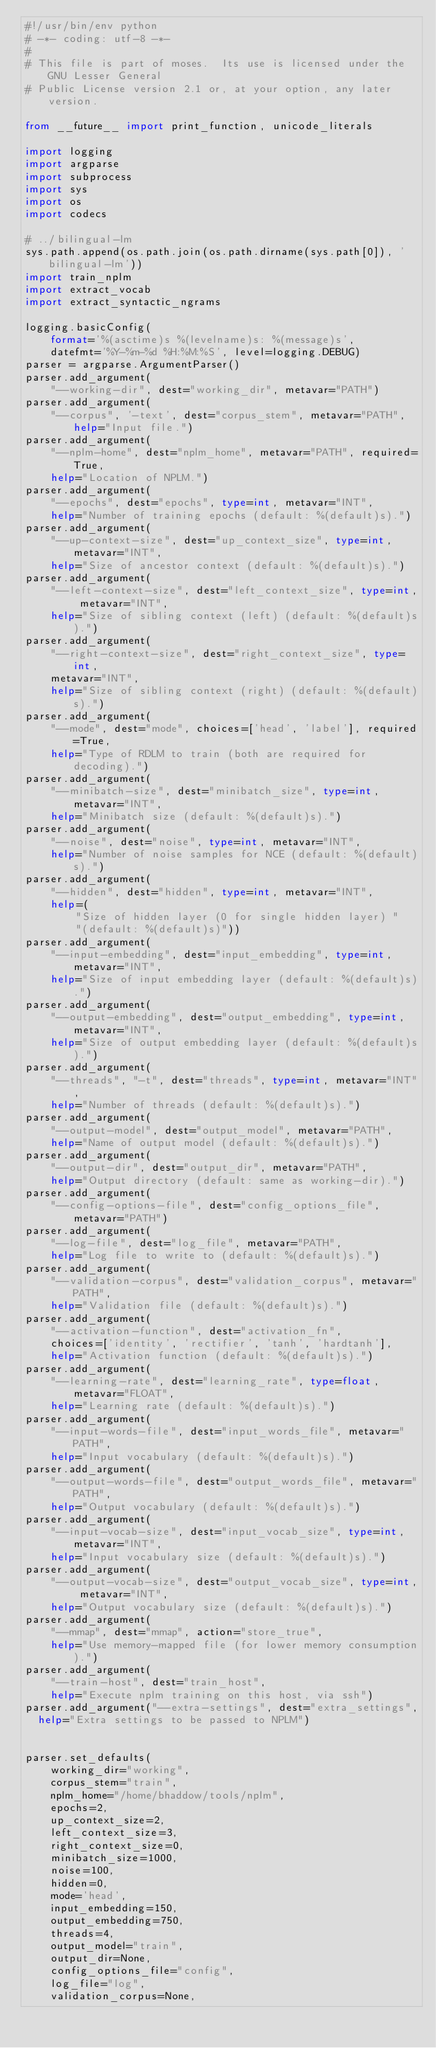<code> <loc_0><loc_0><loc_500><loc_500><_Python_>#!/usr/bin/env python
# -*- coding: utf-8 -*-
#
# This file is part of moses.  Its use is licensed under the GNU Lesser General
# Public License version 2.1 or, at your option, any later version.

from __future__ import print_function, unicode_literals

import logging
import argparse
import subprocess
import sys
import os
import codecs

# ../bilingual-lm
sys.path.append(os.path.join(os.path.dirname(sys.path[0]), 'bilingual-lm'))
import train_nplm
import extract_vocab
import extract_syntactic_ngrams

logging.basicConfig(
    format='%(asctime)s %(levelname)s: %(message)s',
    datefmt='%Y-%m-%d %H:%M:%S', level=logging.DEBUG)
parser = argparse.ArgumentParser()
parser.add_argument(
    "--working-dir", dest="working_dir", metavar="PATH")
parser.add_argument(
    "--corpus", '-text', dest="corpus_stem", metavar="PATH", help="Input file.")
parser.add_argument(
    "--nplm-home", dest="nplm_home", metavar="PATH", required=True,
    help="Location of NPLM.")
parser.add_argument(
    "--epochs", dest="epochs", type=int, metavar="INT",
    help="Number of training epochs (default: %(default)s).")
parser.add_argument(
    "--up-context-size", dest="up_context_size", type=int, metavar="INT",
    help="Size of ancestor context (default: %(default)s).")
parser.add_argument(
    "--left-context-size", dest="left_context_size", type=int, metavar="INT",
    help="Size of sibling context (left) (default: %(default)s).")
parser.add_argument(
    "--right-context-size", dest="right_context_size", type=int,
    metavar="INT",
    help="Size of sibling context (right) (default: %(default)s).")
parser.add_argument(
    "--mode", dest="mode", choices=['head', 'label'], required=True,
    help="Type of RDLM to train (both are required for decoding).")
parser.add_argument(
    "--minibatch-size", dest="minibatch_size", type=int, metavar="INT",
    help="Minibatch size (default: %(default)s).")
parser.add_argument(
    "--noise", dest="noise", type=int, metavar="INT",
    help="Number of noise samples for NCE (default: %(default)s).")
parser.add_argument(
    "--hidden", dest="hidden", type=int, metavar="INT",
    help=(
        "Size of hidden layer (0 for single hidden layer) "
        "(default: %(default)s)"))
parser.add_argument(
    "--input-embedding", dest="input_embedding", type=int, metavar="INT",
    help="Size of input embedding layer (default: %(default)s).")
parser.add_argument(
    "--output-embedding", dest="output_embedding", type=int, metavar="INT",
    help="Size of output embedding layer (default: %(default)s).")
parser.add_argument(
    "--threads", "-t", dest="threads", type=int, metavar="INT",
    help="Number of threads (default: %(default)s).")
parser.add_argument(
    "--output-model", dest="output_model", metavar="PATH",
    help="Name of output model (default: %(default)s).")
parser.add_argument(
    "--output-dir", dest="output_dir", metavar="PATH",
    help="Output directory (default: same as working-dir).")
parser.add_argument(
    "--config-options-file", dest="config_options_file", metavar="PATH")
parser.add_argument(
    "--log-file", dest="log_file", metavar="PATH",
    help="Log file to write to (default: %(default)s).")
parser.add_argument(
    "--validation-corpus", dest="validation_corpus", metavar="PATH",
    help="Validation file (default: %(default)s).")
parser.add_argument(
    "--activation-function", dest="activation_fn",
    choices=['identity', 'rectifier', 'tanh', 'hardtanh'],
    help="Activation function (default: %(default)s).")
parser.add_argument(
    "--learning-rate", dest="learning_rate", type=float, metavar="FLOAT",
    help="Learning rate (default: %(default)s).")
parser.add_argument(
    "--input-words-file", dest="input_words_file", metavar="PATH",
    help="Input vocabulary (default: %(default)s).")
parser.add_argument(
    "--output-words-file", dest="output_words_file", metavar="PATH",
    help="Output vocabulary (default: %(default)s).")
parser.add_argument(
    "--input-vocab-size", dest="input_vocab_size", type=int, metavar="INT",
    help="Input vocabulary size (default: %(default)s).")
parser.add_argument(
    "--output-vocab-size", dest="output_vocab_size", type=int, metavar="INT",
    help="Output vocabulary size (default: %(default)s).")
parser.add_argument(
    "--mmap", dest="mmap", action="store_true",
    help="Use memory-mapped file (for lower memory consumption).")
parser.add_argument(
    "--train-host", dest="train_host",
    help="Execute nplm training on this host, via ssh")
parser.add_argument("--extra-settings", dest="extra_settings",
  help="Extra settings to be passed to NPLM")


parser.set_defaults(
    working_dir="working",
    corpus_stem="train",
    nplm_home="/home/bhaddow/tools/nplm",
    epochs=2,
    up_context_size=2,
    left_context_size=3,
    right_context_size=0,
    minibatch_size=1000,
    noise=100,
    hidden=0,
    mode='head',
    input_embedding=150,
    output_embedding=750,
    threads=4,
    output_model="train",
    output_dir=None,
    config_options_file="config",
    log_file="log",
    validation_corpus=None,</code> 